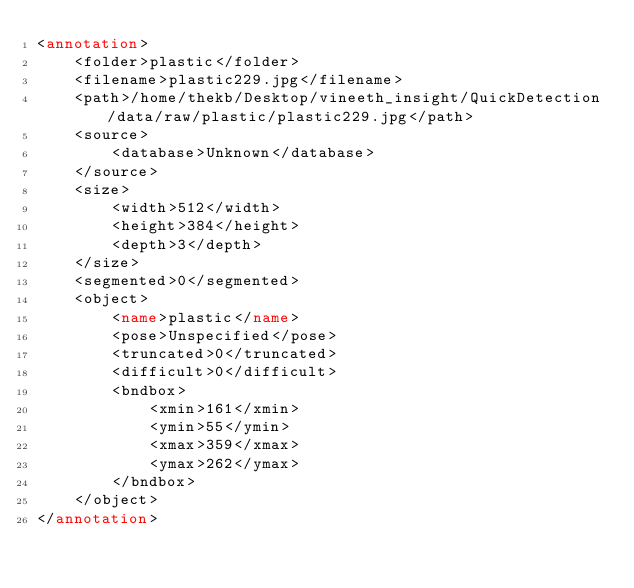Convert code to text. <code><loc_0><loc_0><loc_500><loc_500><_XML_><annotation>
	<folder>plastic</folder>
	<filename>plastic229.jpg</filename>
	<path>/home/thekb/Desktop/vineeth_insight/QuickDetection/data/raw/plastic/plastic229.jpg</path>
	<source>
		<database>Unknown</database>
	</source>
	<size>
		<width>512</width>
		<height>384</height>
		<depth>3</depth>
	</size>
	<segmented>0</segmented>
	<object>
		<name>plastic</name>
		<pose>Unspecified</pose>
		<truncated>0</truncated>
		<difficult>0</difficult>
		<bndbox>
			<xmin>161</xmin>
			<ymin>55</ymin>
			<xmax>359</xmax>
			<ymax>262</ymax>
		</bndbox>
	</object>
</annotation>
</code> 